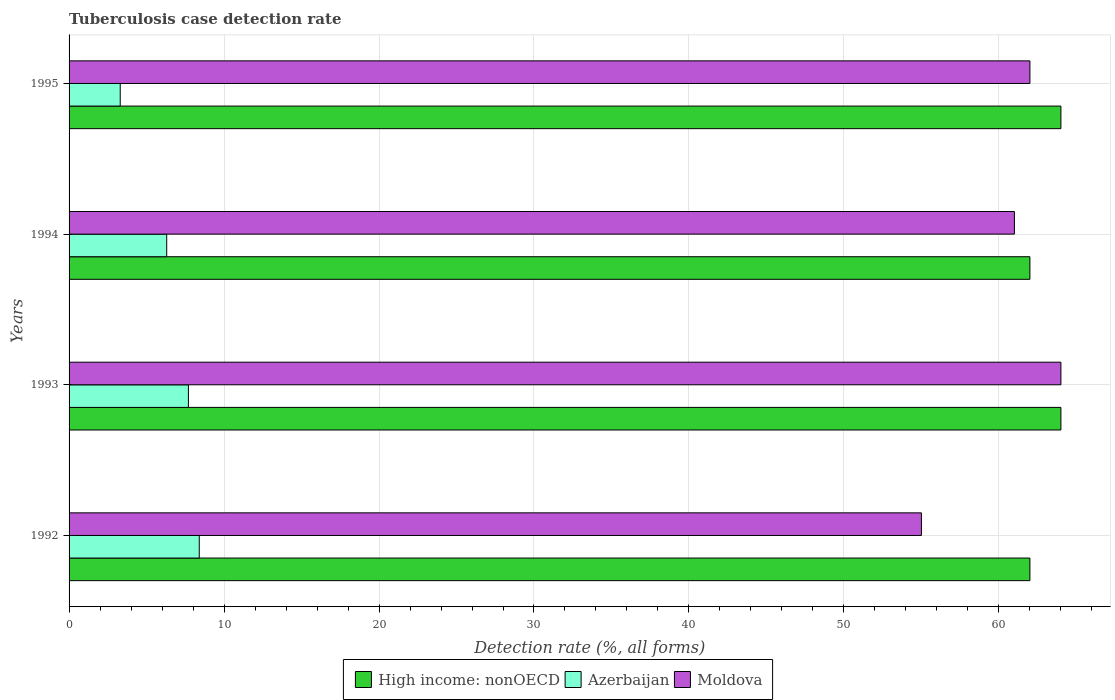How many groups of bars are there?
Provide a succinct answer. 4. Are the number of bars on each tick of the Y-axis equal?
Your response must be concise. Yes. What is the label of the 4th group of bars from the top?
Your answer should be very brief. 1992. In how many cases, is the number of bars for a given year not equal to the number of legend labels?
Offer a terse response. 0. What is the tuberculosis case detection rate in in High income: nonOECD in 1993?
Provide a succinct answer. 64. Across all years, what is the maximum tuberculosis case detection rate in in High income: nonOECD?
Provide a short and direct response. 64. Across all years, what is the minimum tuberculosis case detection rate in in High income: nonOECD?
Your answer should be compact. 62. In which year was the tuberculosis case detection rate in in Moldova maximum?
Make the answer very short. 1993. In which year was the tuberculosis case detection rate in in Azerbaijan minimum?
Your answer should be compact. 1995. What is the total tuberculosis case detection rate in in Moldova in the graph?
Offer a terse response. 242. What is the difference between the tuberculosis case detection rate in in High income: nonOECD in 1992 and that in 1994?
Keep it short and to the point. 0. What is the difference between the tuberculosis case detection rate in in High income: nonOECD in 1993 and the tuberculosis case detection rate in in Azerbaijan in 1994?
Give a very brief answer. 57.7. What is the average tuberculosis case detection rate in in Azerbaijan per year?
Keep it short and to the point. 6.43. In the year 1993, what is the difference between the tuberculosis case detection rate in in High income: nonOECD and tuberculosis case detection rate in in Moldova?
Ensure brevity in your answer.  0. What is the ratio of the tuberculosis case detection rate in in High income: nonOECD in 1992 to that in 1993?
Offer a very short reply. 0.97. Is the tuberculosis case detection rate in in Moldova in 1992 less than that in 1995?
Ensure brevity in your answer.  Yes. What is the difference between the highest and the second highest tuberculosis case detection rate in in Azerbaijan?
Keep it short and to the point. 0.7. What is the difference between the highest and the lowest tuberculosis case detection rate in in Moldova?
Offer a terse response. 9. Is the sum of the tuberculosis case detection rate in in Moldova in 1992 and 1993 greater than the maximum tuberculosis case detection rate in in Azerbaijan across all years?
Offer a terse response. Yes. What does the 2nd bar from the top in 1994 represents?
Ensure brevity in your answer.  Azerbaijan. What does the 3rd bar from the bottom in 1995 represents?
Ensure brevity in your answer.  Moldova. Is it the case that in every year, the sum of the tuberculosis case detection rate in in Moldova and tuberculosis case detection rate in in High income: nonOECD is greater than the tuberculosis case detection rate in in Azerbaijan?
Make the answer very short. Yes. Are all the bars in the graph horizontal?
Ensure brevity in your answer.  Yes. How many years are there in the graph?
Ensure brevity in your answer.  4. What is the difference between two consecutive major ticks on the X-axis?
Provide a short and direct response. 10. Does the graph contain any zero values?
Offer a very short reply. No. What is the title of the graph?
Give a very brief answer. Tuberculosis case detection rate. What is the label or title of the X-axis?
Provide a succinct answer. Detection rate (%, all forms). What is the label or title of the Y-axis?
Give a very brief answer. Years. What is the Detection rate (%, all forms) in High income: nonOECD in 1992?
Your answer should be compact. 62. What is the Detection rate (%, all forms) of Moldova in 1992?
Provide a succinct answer. 55. What is the Detection rate (%, all forms) in Moldova in 1993?
Provide a succinct answer. 64. What is the Detection rate (%, all forms) of Azerbaijan in 1995?
Provide a short and direct response. 3.3. What is the Detection rate (%, all forms) of Moldova in 1995?
Provide a succinct answer. 62. Across all years, what is the maximum Detection rate (%, all forms) in Moldova?
Offer a terse response. 64. Across all years, what is the minimum Detection rate (%, all forms) in High income: nonOECD?
Give a very brief answer. 62. Across all years, what is the minimum Detection rate (%, all forms) in Azerbaijan?
Offer a very short reply. 3.3. Across all years, what is the minimum Detection rate (%, all forms) in Moldova?
Offer a terse response. 55. What is the total Detection rate (%, all forms) of High income: nonOECD in the graph?
Offer a very short reply. 252. What is the total Detection rate (%, all forms) of Azerbaijan in the graph?
Your answer should be very brief. 25.7. What is the total Detection rate (%, all forms) of Moldova in the graph?
Ensure brevity in your answer.  242. What is the difference between the Detection rate (%, all forms) of High income: nonOECD in 1992 and that in 1993?
Ensure brevity in your answer.  -2. What is the difference between the Detection rate (%, all forms) of Moldova in 1992 and that in 1993?
Your response must be concise. -9. What is the difference between the Detection rate (%, all forms) of High income: nonOECD in 1992 and that in 1994?
Your answer should be compact. 0. What is the difference between the Detection rate (%, all forms) in Azerbaijan in 1992 and that in 1994?
Ensure brevity in your answer.  2.1. What is the difference between the Detection rate (%, all forms) in Moldova in 1992 and that in 1994?
Your response must be concise. -6. What is the difference between the Detection rate (%, all forms) of High income: nonOECD in 1992 and that in 1995?
Offer a terse response. -2. What is the difference between the Detection rate (%, all forms) of Azerbaijan in 1992 and that in 1995?
Offer a terse response. 5.1. What is the difference between the Detection rate (%, all forms) of Moldova in 1992 and that in 1995?
Provide a succinct answer. -7. What is the difference between the Detection rate (%, all forms) of High income: nonOECD in 1993 and that in 1994?
Make the answer very short. 2. What is the difference between the Detection rate (%, all forms) of Azerbaijan in 1993 and that in 1994?
Give a very brief answer. 1.4. What is the difference between the Detection rate (%, all forms) in Moldova in 1993 and that in 1994?
Provide a short and direct response. 3. What is the difference between the Detection rate (%, all forms) in Moldova in 1993 and that in 1995?
Give a very brief answer. 2. What is the difference between the Detection rate (%, all forms) of Azerbaijan in 1994 and that in 1995?
Ensure brevity in your answer.  3. What is the difference between the Detection rate (%, all forms) in High income: nonOECD in 1992 and the Detection rate (%, all forms) in Azerbaijan in 1993?
Keep it short and to the point. 54.3. What is the difference between the Detection rate (%, all forms) of Azerbaijan in 1992 and the Detection rate (%, all forms) of Moldova in 1993?
Keep it short and to the point. -55.6. What is the difference between the Detection rate (%, all forms) of High income: nonOECD in 1992 and the Detection rate (%, all forms) of Azerbaijan in 1994?
Provide a succinct answer. 55.7. What is the difference between the Detection rate (%, all forms) in Azerbaijan in 1992 and the Detection rate (%, all forms) in Moldova in 1994?
Give a very brief answer. -52.6. What is the difference between the Detection rate (%, all forms) of High income: nonOECD in 1992 and the Detection rate (%, all forms) of Azerbaijan in 1995?
Keep it short and to the point. 58.7. What is the difference between the Detection rate (%, all forms) of Azerbaijan in 1992 and the Detection rate (%, all forms) of Moldova in 1995?
Your answer should be compact. -53.6. What is the difference between the Detection rate (%, all forms) in High income: nonOECD in 1993 and the Detection rate (%, all forms) in Azerbaijan in 1994?
Give a very brief answer. 57.7. What is the difference between the Detection rate (%, all forms) in Azerbaijan in 1993 and the Detection rate (%, all forms) in Moldova in 1994?
Offer a terse response. -53.3. What is the difference between the Detection rate (%, all forms) of High income: nonOECD in 1993 and the Detection rate (%, all forms) of Azerbaijan in 1995?
Offer a terse response. 60.7. What is the difference between the Detection rate (%, all forms) in Azerbaijan in 1993 and the Detection rate (%, all forms) in Moldova in 1995?
Provide a succinct answer. -54.3. What is the difference between the Detection rate (%, all forms) of High income: nonOECD in 1994 and the Detection rate (%, all forms) of Azerbaijan in 1995?
Your answer should be very brief. 58.7. What is the difference between the Detection rate (%, all forms) of Azerbaijan in 1994 and the Detection rate (%, all forms) of Moldova in 1995?
Offer a very short reply. -55.7. What is the average Detection rate (%, all forms) of Azerbaijan per year?
Your response must be concise. 6.42. What is the average Detection rate (%, all forms) in Moldova per year?
Give a very brief answer. 60.5. In the year 1992, what is the difference between the Detection rate (%, all forms) of High income: nonOECD and Detection rate (%, all forms) of Azerbaijan?
Your answer should be compact. 53.6. In the year 1992, what is the difference between the Detection rate (%, all forms) in Azerbaijan and Detection rate (%, all forms) in Moldova?
Provide a succinct answer. -46.6. In the year 1993, what is the difference between the Detection rate (%, all forms) in High income: nonOECD and Detection rate (%, all forms) in Azerbaijan?
Your answer should be compact. 56.3. In the year 1993, what is the difference between the Detection rate (%, all forms) of High income: nonOECD and Detection rate (%, all forms) of Moldova?
Keep it short and to the point. 0. In the year 1993, what is the difference between the Detection rate (%, all forms) in Azerbaijan and Detection rate (%, all forms) in Moldova?
Your answer should be compact. -56.3. In the year 1994, what is the difference between the Detection rate (%, all forms) in High income: nonOECD and Detection rate (%, all forms) in Azerbaijan?
Give a very brief answer. 55.7. In the year 1994, what is the difference between the Detection rate (%, all forms) in High income: nonOECD and Detection rate (%, all forms) in Moldova?
Make the answer very short. 1. In the year 1994, what is the difference between the Detection rate (%, all forms) of Azerbaijan and Detection rate (%, all forms) of Moldova?
Provide a short and direct response. -54.7. In the year 1995, what is the difference between the Detection rate (%, all forms) of High income: nonOECD and Detection rate (%, all forms) of Azerbaijan?
Offer a very short reply. 60.7. In the year 1995, what is the difference between the Detection rate (%, all forms) in Azerbaijan and Detection rate (%, all forms) in Moldova?
Keep it short and to the point. -58.7. What is the ratio of the Detection rate (%, all forms) of High income: nonOECD in 1992 to that in 1993?
Your answer should be very brief. 0.97. What is the ratio of the Detection rate (%, all forms) of Moldova in 1992 to that in 1993?
Offer a terse response. 0.86. What is the ratio of the Detection rate (%, all forms) in High income: nonOECD in 1992 to that in 1994?
Offer a very short reply. 1. What is the ratio of the Detection rate (%, all forms) in Moldova in 1992 to that in 1994?
Provide a succinct answer. 0.9. What is the ratio of the Detection rate (%, all forms) in High income: nonOECD in 1992 to that in 1995?
Your answer should be very brief. 0.97. What is the ratio of the Detection rate (%, all forms) of Azerbaijan in 1992 to that in 1995?
Keep it short and to the point. 2.55. What is the ratio of the Detection rate (%, all forms) in Moldova in 1992 to that in 1995?
Provide a short and direct response. 0.89. What is the ratio of the Detection rate (%, all forms) in High income: nonOECD in 1993 to that in 1994?
Keep it short and to the point. 1.03. What is the ratio of the Detection rate (%, all forms) of Azerbaijan in 1993 to that in 1994?
Keep it short and to the point. 1.22. What is the ratio of the Detection rate (%, all forms) in Moldova in 1993 to that in 1994?
Provide a short and direct response. 1.05. What is the ratio of the Detection rate (%, all forms) in High income: nonOECD in 1993 to that in 1995?
Your answer should be very brief. 1. What is the ratio of the Detection rate (%, all forms) of Azerbaijan in 1993 to that in 1995?
Offer a terse response. 2.33. What is the ratio of the Detection rate (%, all forms) in Moldova in 1993 to that in 1995?
Give a very brief answer. 1.03. What is the ratio of the Detection rate (%, all forms) of High income: nonOECD in 1994 to that in 1995?
Keep it short and to the point. 0.97. What is the ratio of the Detection rate (%, all forms) in Azerbaijan in 1994 to that in 1995?
Ensure brevity in your answer.  1.91. What is the ratio of the Detection rate (%, all forms) in Moldova in 1994 to that in 1995?
Give a very brief answer. 0.98. What is the difference between the highest and the second highest Detection rate (%, all forms) of High income: nonOECD?
Ensure brevity in your answer.  0. What is the difference between the highest and the lowest Detection rate (%, all forms) of High income: nonOECD?
Ensure brevity in your answer.  2. What is the difference between the highest and the lowest Detection rate (%, all forms) of Moldova?
Ensure brevity in your answer.  9. 